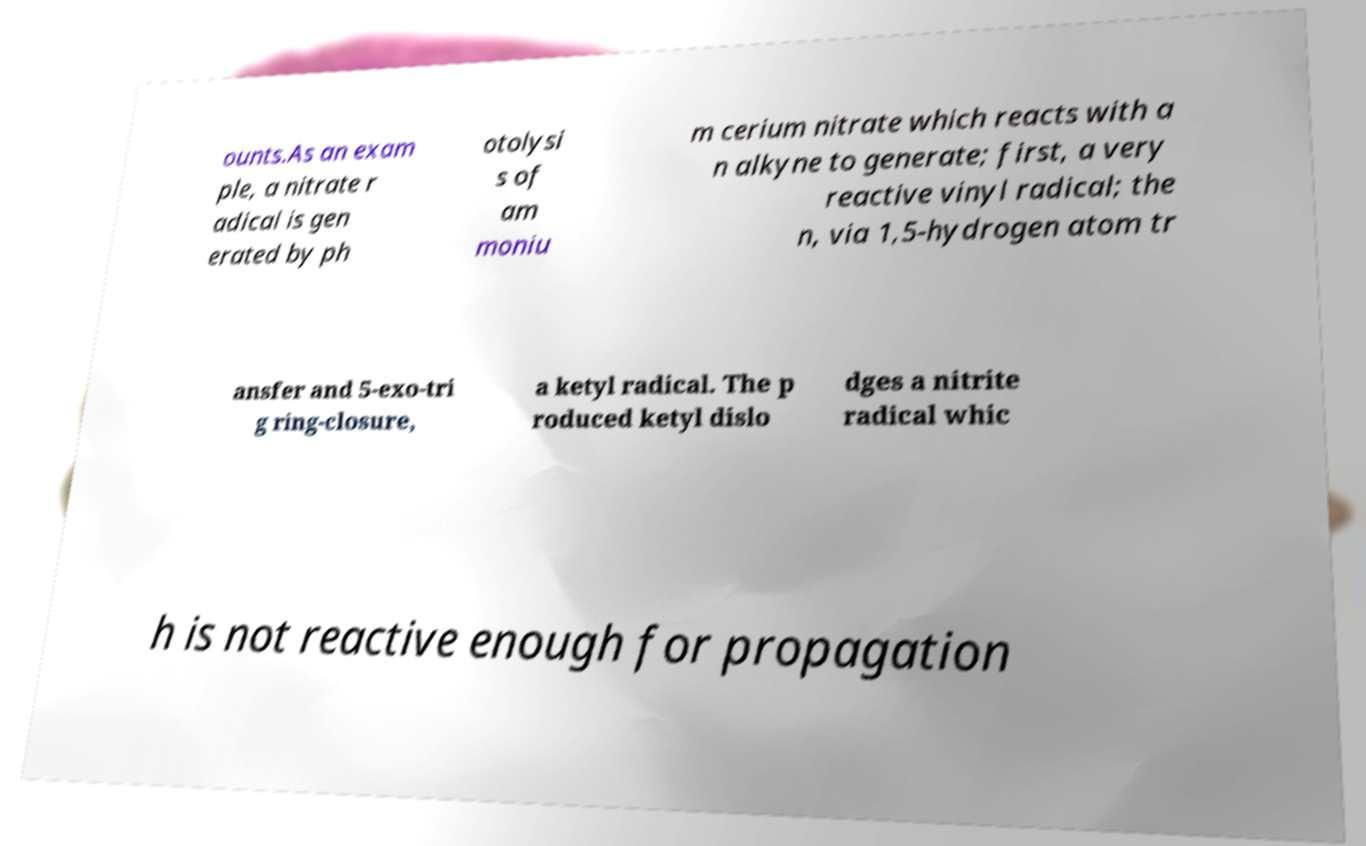There's text embedded in this image that I need extracted. Can you transcribe it verbatim? ounts.As an exam ple, a nitrate r adical is gen erated by ph otolysi s of am moniu m cerium nitrate which reacts with a n alkyne to generate; first, a very reactive vinyl radical; the n, via 1,5-hydrogen atom tr ansfer and 5-exo-tri g ring-closure, a ketyl radical. The p roduced ketyl dislo dges a nitrite radical whic h is not reactive enough for propagation 